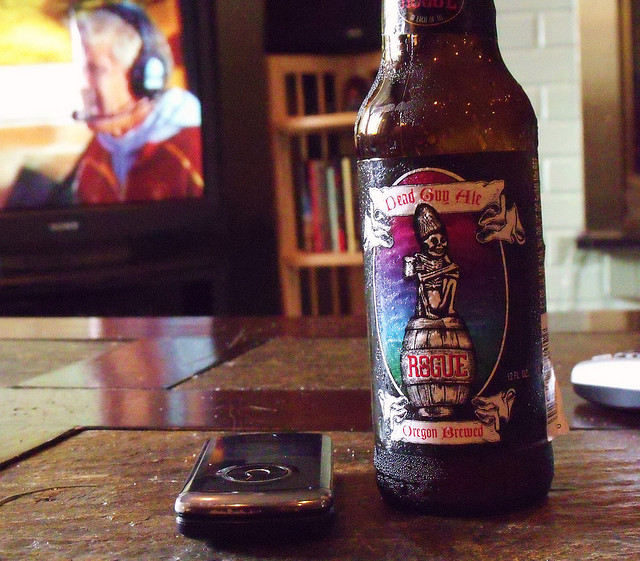Identify the text contained in this image. Dead RGGUE Oregon 